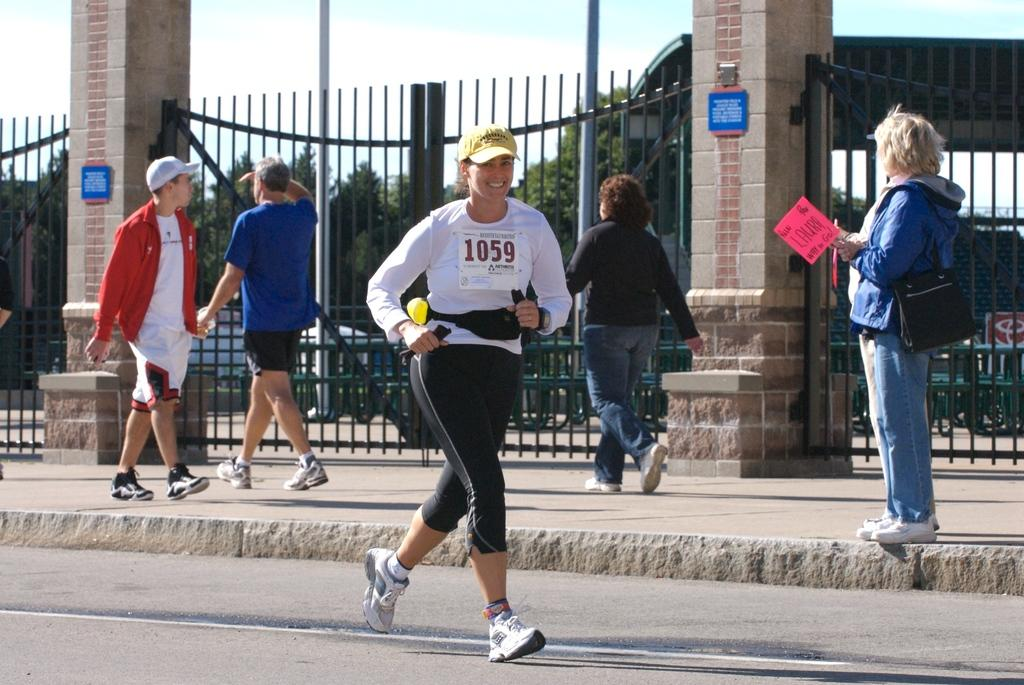What is the woman in the image doing? The woman is running on a road in the image. What can be seen in the background of the image? There are people walking on a footpath, trees, and the sky visible in the background. What architectural features are present in the image? There is a railing and pillars visible in the image. What type of trousers is the snow wearing in the image? There is no snow or trousers present in the image; it features a woman running on a road and people walking on a footpath. What kind of ray can be seen interacting with the pillars in the image? There is no ray present in the image; it only features a woman running, people walking, a railing, pillars, trees, and the sky. 